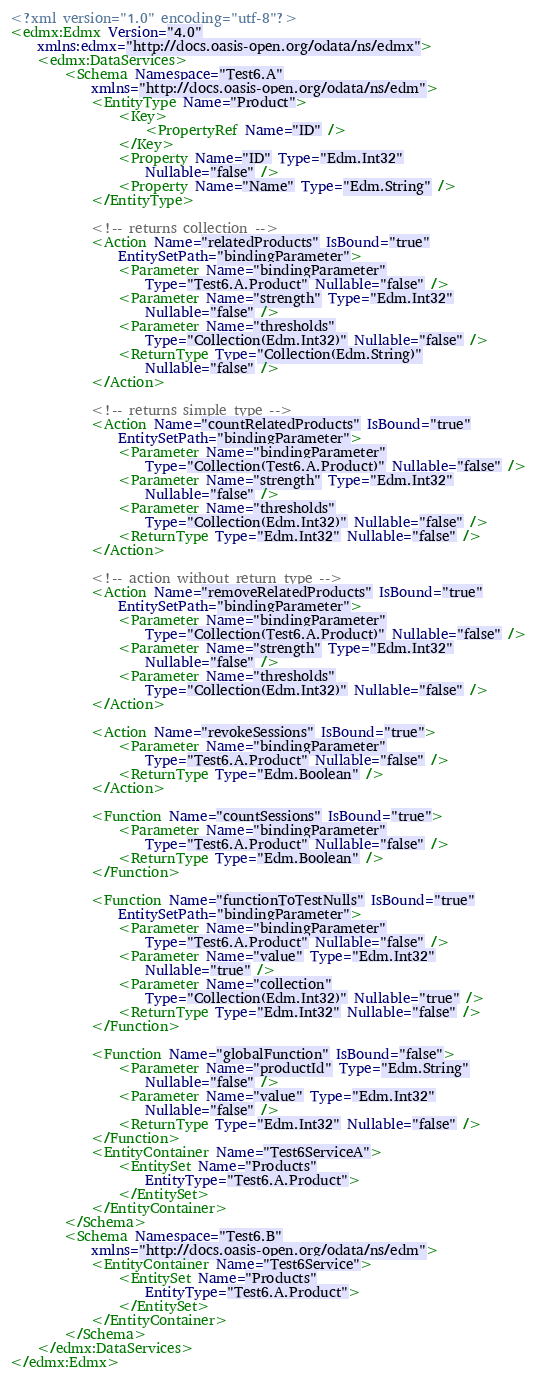Convert code to text. <code><loc_0><loc_0><loc_500><loc_500><_XML_><?xml version="1.0" encoding="utf-8"?>
<edmx:Edmx Version="4.0"
    xmlns:edmx="http://docs.oasis-open.org/odata/ns/edmx">
    <edmx:DataServices>
        <Schema Namespace="Test6.A"
            xmlns="http://docs.oasis-open.org/odata/ns/edm">
            <EntityType Name="Product">
                <Key>
                    <PropertyRef Name="ID" />
                </Key>
                <Property Name="ID" Type="Edm.Int32"
                    Nullable="false" />
                <Property Name="Name" Type="Edm.String" />
            </EntityType>

            <!-- returns collection -->
            <Action Name="relatedProducts" IsBound="true"
                EntitySetPath="bindingParameter">
                <Parameter Name="bindingParameter"
                    Type="Test6.A.Product" Nullable="false" />
                <Parameter Name="strength" Type="Edm.Int32"
                    Nullable="false" />
                <Parameter Name="thresholds"
                    Type="Collection(Edm.Int32)" Nullable="false" />
                <ReturnType Type="Collection(Edm.String)"
                    Nullable="false" />
            </Action>

            <!-- returns simple type -->
            <Action Name="countRelatedProducts" IsBound="true"
                EntitySetPath="bindingParameter">
                <Parameter Name="bindingParameter"
                    Type="Collection(Test6.A.Product)" Nullable="false" />
                <Parameter Name="strength" Type="Edm.Int32"
                    Nullable="false" />
                <Parameter Name="thresholds"
                    Type="Collection(Edm.Int32)" Nullable="false" />
                <ReturnType Type="Edm.Int32" Nullable="false" />
            </Action>

            <!-- action without return type -->
            <Action Name="removeRelatedProducts" IsBound="true"
                EntitySetPath="bindingParameter">
                <Parameter Name="bindingParameter"
                    Type="Collection(Test6.A.Product)" Nullable="false" />
                <Parameter Name="strength" Type="Edm.Int32"
                    Nullable="false" />
                <Parameter Name="thresholds"
                    Type="Collection(Edm.Int32)" Nullable="false" />
            </Action>

            <Action Name="revokeSessions" IsBound="true">
                <Parameter Name="bindingParameter"
                    Type="Test6.A.Product" Nullable="false" />
                <ReturnType Type="Edm.Boolean" />
            </Action>

            <Function Name="countSessions" IsBound="true">
                <Parameter Name="bindingParameter"
                    Type="Test6.A.Product" Nullable="false" />
                <ReturnType Type="Edm.Boolean" />
            </Function>

            <Function Name="functionToTestNulls" IsBound="true"
                EntitySetPath="bindingParameter">
                <Parameter Name="bindingParameter"
                    Type="Test6.A.Product" Nullable="false" />
                <Parameter Name="value" Type="Edm.Int32"
                    Nullable="true" />
                <Parameter Name="collection"
                    Type="Collection(Edm.Int32)" Nullable="true" />
                <ReturnType Type="Edm.Int32" Nullable="false" />
            </Function>

            <Function Name="globalFunction" IsBound="false">
                <Parameter Name="productId" Type="Edm.String"
                    Nullable="false" />
                <Parameter Name="value" Type="Edm.Int32"
                    Nullable="false" />
                <ReturnType Type="Edm.Int32" Nullable="false" />
            </Function>
            <EntityContainer Name="Test6ServiceA">
                <EntitySet Name="Products"
                    EntityType="Test6.A.Product">
                </EntitySet>
            </EntityContainer>
        </Schema>
        <Schema Namespace="Test6.B"
            xmlns="http://docs.oasis-open.org/odata/ns/edm">
            <EntityContainer Name="Test6Service">
                <EntitySet Name="Products"
                    EntityType="Test6.A.Product">
                </EntitySet>
            </EntityContainer>
        </Schema>
    </edmx:DataServices>
</edmx:Edmx></code> 